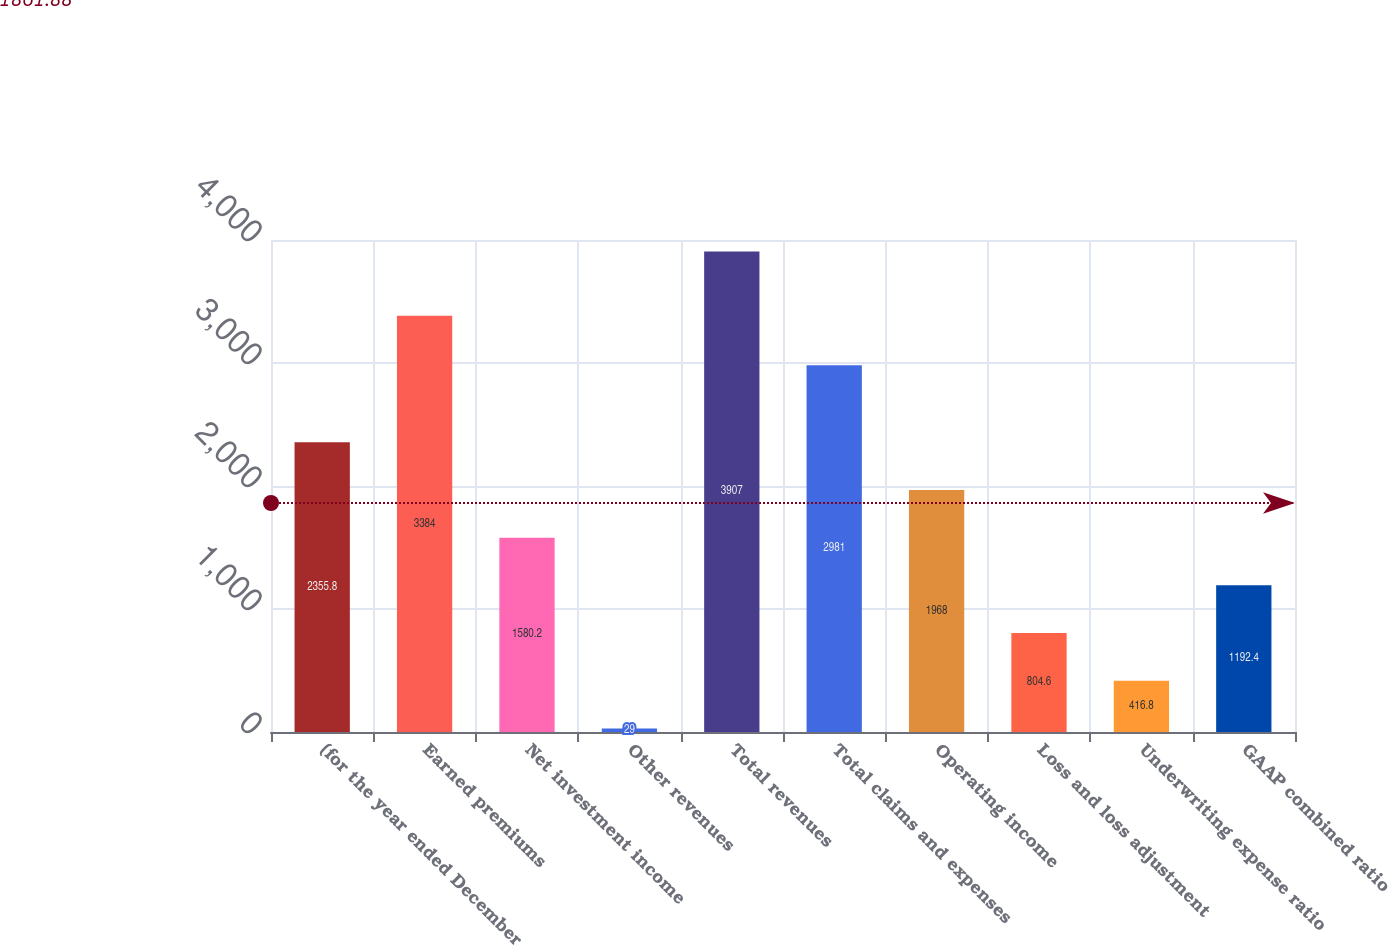Convert chart to OTSL. <chart><loc_0><loc_0><loc_500><loc_500><bar_chart><fcel>(for the year ended December<fcel>Earned premiums<fcel>Net investment income<fcel>Other revenues<fcel>Total revenues<fcel>Total claims and expenses<fcel>Operating income<fcel>Loss and loss adjustment<fcel>Underwriting expense ratio<fcel>GAAP combined ratio<nl><fcel>2355.8<fcel>3384<fcel>1580.2<fcel>29<fcel>3907<fcel>2981<fcel>1968<fcel>804.6<fcel>416.8<fcel>1192.4<nl></chart> 